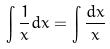Convert formula to latex. <formula><loc_0><loc_0><loc_500><loc_500>\int \frac { 1 } { x } d x = \int \frac { d x } { x }</formula> 